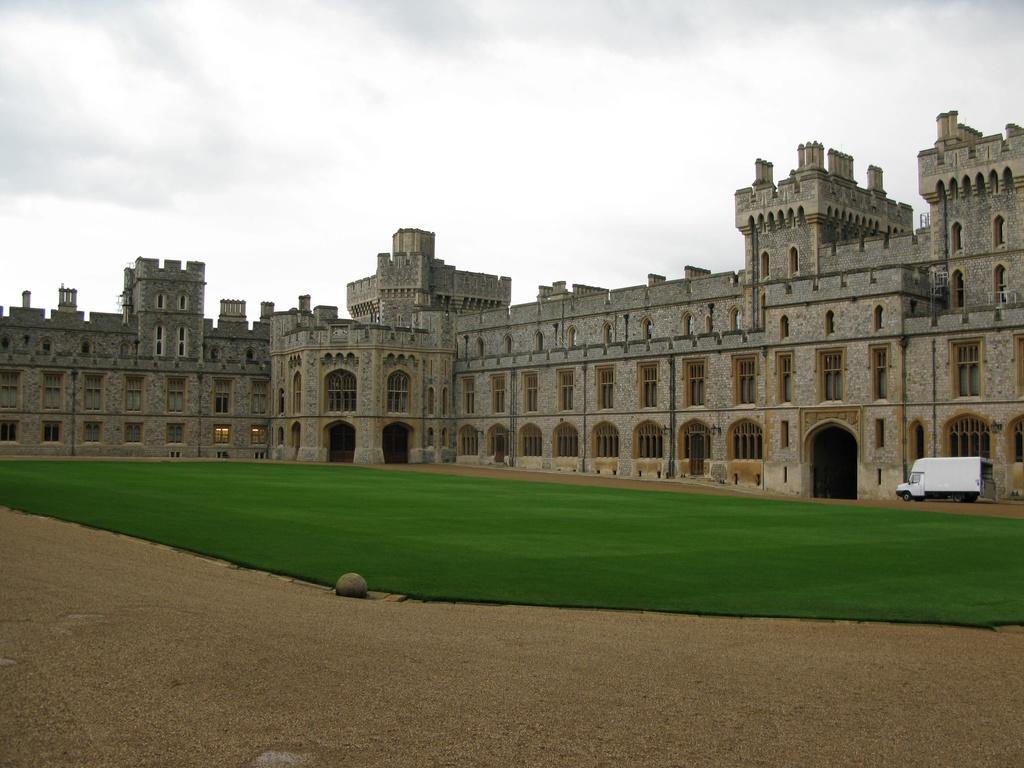How would you summarize this image in a sentence or two? This image looks like a fort, there are windows. There is a vehicle on the right corner. There is grass, there is ground at the bottom. And there is sky at the top. 